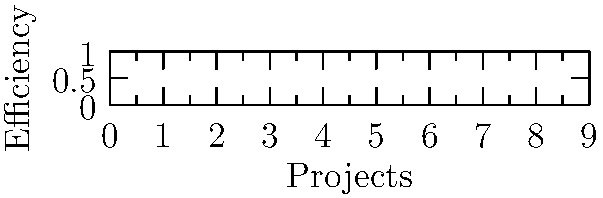As a philanthropic organization, you're evaluating the efficiency of resource utilization across various policy projects. The scatter plot shows the efficiency scores for 8 projects (A to H). Which project should be prioritized for additional funding to maximize impact, assuming that projects with high efficiency scores but room for improvement are ideal candidates? To answer this question, we need to analyze the scatter plot and consider both the efficiency scores and potential for improvement:

1. Identify the projects with high efficiency scores:
   - Project G: 0.95
   - Project D: 0.90
   - Project F: 0.85
   - Projects B and H: 0.80

2. Among these high-performing projects, we need to consider which ones have room for improvement:
   - Project G is already at 0.95, leaving little room for improvement
   - Project D at 0.90 has some room for improvement
   - Projects F, B, and H have more room for improvement

3. Consider the potential impact of additional funding:
   - Project F, with a score of 0.85, shows high efficiency but still has a significant margin for improvement
   - It's positioned in the middle of the high-performing group, suggesting a balance between proven efficiency and growth potential

4. Evaluate the risk-reward ratio:
   - Project F represents a lower risk compared to lower-scoring projects, but higher potential rewards compared to the highest-scoring projects

Therefore, Project F emerges as the ideal candidate for additional funding. It demonstrates high efficiency (0.85) while still having room for improvement, potentially allowing the philanthropic organization to maximize its impact through targeted support.
Answer: Project F 